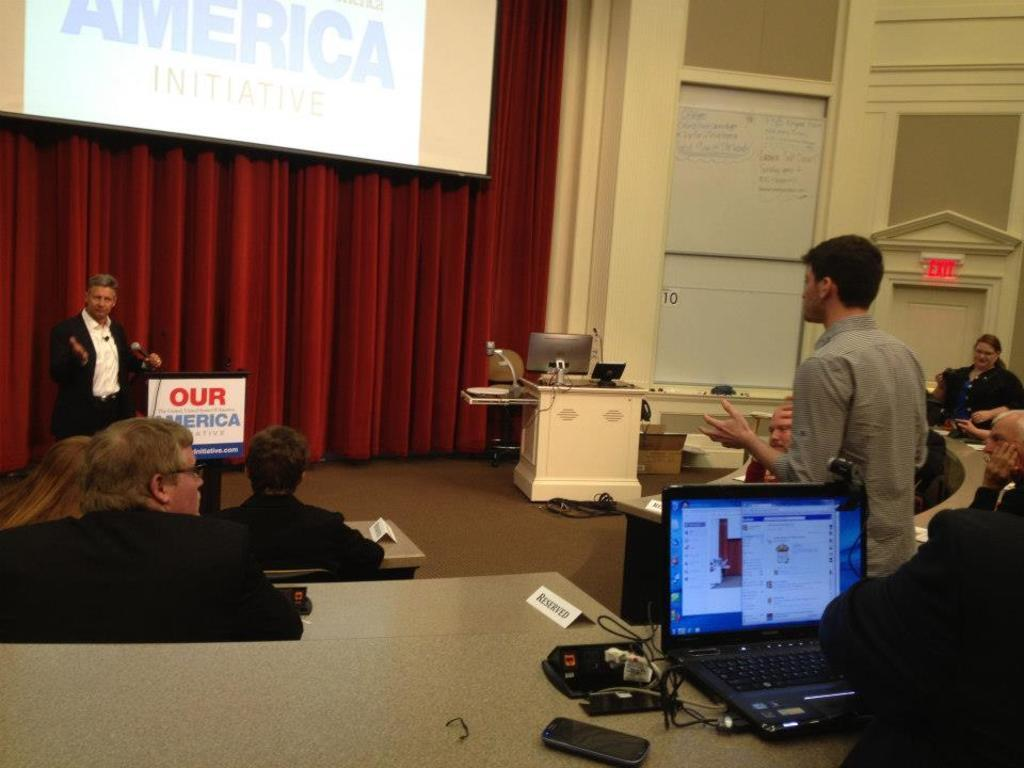<image>
Create a compact narrative representing the image presented. People watching a presentation with a banner in front that says America. 